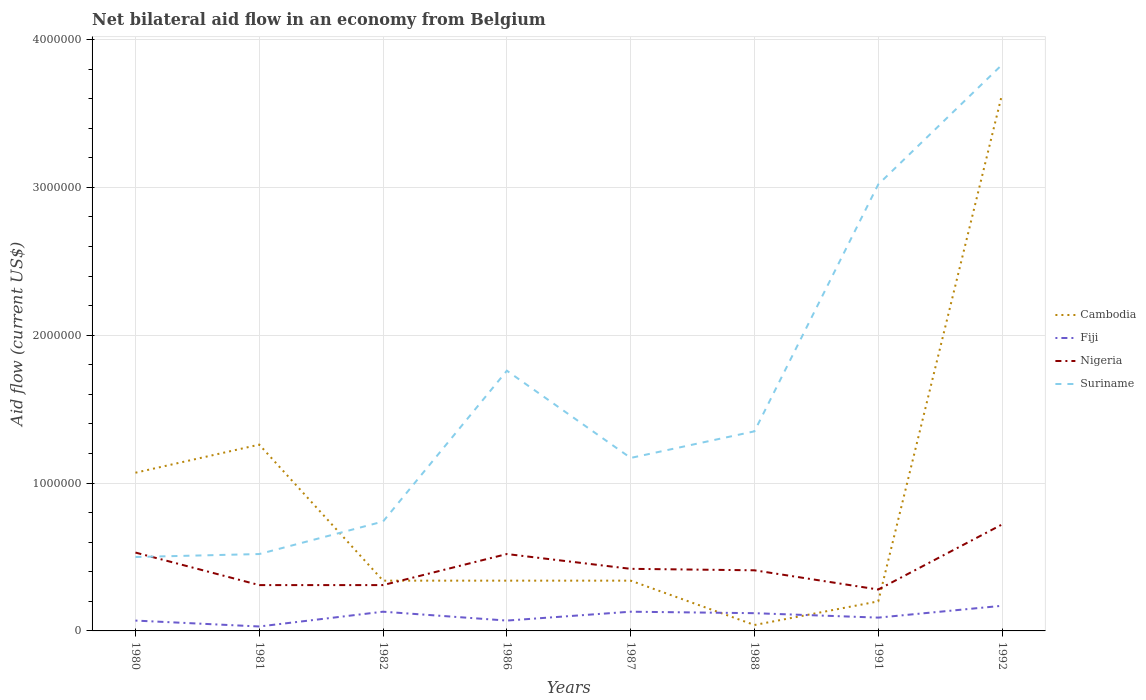Does the line corresponding to Suriname intersect with the line corresponding to Nigeria?
Your answer should be compact. Yes. Is the number of lines equal to the number of legend labels?
Offer a very short reply. Yes. What is the difference between the highest and the second highest net bilateral aid flow in Suriname?
Provide a short and direct response. 3.33e+06. What is the difference between the highest and the lowest net bilateral aid flow in Fiji?
Provide a succinct answer. 4. How many lines are there?
Ensure brevity in your answer.  4. Are the values on the major ticks of Y-axis written in scientific E-notation?
Ensure brevity in your answer.  No. Does the graph contain grids?
Provide a succinct answer. Yes. How many legend labels are there?
Offer a very short reply. 4. How are the legend labels stacked?
Provide a short and direct response. Vertical. What is the title of the graph?
Offer a terse response. Net bilateral aid flow in an economy from Belgium. Does "Least developed countries" appear as one of the legend labels in the graph?
Offer a terse response. No. What is the label or title of the Y-axis?
Your answer should be very brief. Aid flow (current US$). What is the Aid flow (current US$) of Cambodia in 1980?
Provide a short and direct response. 1.07e+06. What is the Aid flow (current US$) in Fiji in 1980?
Make the answer very short. 7.00e+04. What is the Aid flow (current US$) of Nigeria in 1980?
Offer a terse response. 5.30e+05. What is the Aid flow (current US$) in Suriname in 1980?
Offer a terse response. 5.00e+05. What is the Aid flow (current US$) of Cambodia in 1981?
Provide a short and direct response. 1.26e+06. What is the Aid flow (current US$) of Fiji in 1981?
Provide a short and direct response. 3.00e+04. What is the Aid flow (current US$) of Nigeria in 1981?
Give a very brief answer. 3.10e+05. What is the Aid flow (current US$) of Suriname in 1981?
Your answer should be very brief. 5.20e+05. What is the Aid flow (current US$) of Fiji in 1982?
Your response must be concise. 1.30e+05. What is the Aid flow (current US$) of Suriname in 1982?
Your answer should be very brief. 7.40e+05. What is the Aid flow (current US$) of Fiji in 1986?
Your answer should be compact. 7.00e+04. What is the Aid flow (current US$) in Nigeria in 1986?
Your answer should be compact. 5.20e+05. What is the Aid flow (current US$) in Suriname in 1986?
Keep it short and to the point. 1.76e+06. What is the Aid flow (current US$) in Nigeria in 1987?
Provide a succinct answer. 4.20e+05. What is the Aid flow (current US$) of Suriname in 1987?
Your answer should be very brief. 1.17e+06. What is the Aid flow (current US$) of Cambodia in 1988?
Your response must be concise. 4.00e+04. What is the Aid flow (current US$) of Fiji in 1988?
Your answer should be compact. 1.20e+05. What is the Aid flow (current US$) in Suriname in 1988?
Offer a terse response. 1.35e+06. What is the Aid flow (current US$) of Nigeria in 1991?
Offer a very short reply. 2.80e+05. What is the Aid flow (current US$) of Suriname in 1991?
Offer a very short reply. 3.02e+06. What is the Aid flow (current US$) in Cambodia in 1992?
Make the answer very short. 3.63e+06. What is the Aid flow (current US$) in Fiji in 1992?
Provide a short and direct response. 1.70e+05. What is the Aid flow (current US$) of Nigeria in 1992?
Your response must be concise. 7.20e+05. What is the Aid flow (current US$) in Suriname in 1992?
Provide a short and direct response. 3.83e+06. Across all years, what is the maximum Aid flow (current US$) in Cambodia?
Make the answer very short. 3.63e+06. Across all years, what is the maximum Aid flow (current US$) of Fiji?
Your response must be concise. 1.70e+05. Across all years, what is the maximum Aid flow (current US$) in Nigeria?
Provide a succinct answer. 7.20e+05. Across all years, what is the maximum Aid flow (current US$) in Suriname?
Offer a very short reply. 3.83e+06. Across all years, what is the minimum Aid flow (current US$) of Nigeria?
Keep it short and to the point. 2.80e+05. What is the total Aid flow (current US$) of Cambodia in the graph?
Provide a short and direct response. 7.22e+06. What is the total Aid flow (current US$) in Fiji in the graph?
Provide a short and direct response. 8.10e+05. What is the total Aid flow (current US$) in Nigeria in the graph?
Ensure brevity in your answer.  3.50e+06. What is the total Aid flow (current US$) in Suriname in the graph?
Your answer should be compact. 1.29e+07. What is the difference between the Aid flow (current US$) in Cambodia in 1980 and that in 1981?
Make the answer very short. -1.90e+05. What is the difference between the Aid flow (current US$) of Suriname in 1980 and that in 1981?
Keep it short and to the point. -2.00e+04. What is the difference between the Aid flow (current US$) in Cambodia in 1980 and that in 1982?
Offer a terse response. 7.30e+05. What is the difference between the Aid flow (current US$) in Fiji in 1980 and that in 1982?
Make the answer very short. -6.00e+04. What is the difference between the Aid flow (current US$) in Nigeria in 1980 and that in 1982?
Keep it short and to the point. 2.20e+05. What is the difference between the Aid flow (current US$) in Suriname in 1980 and that in 1982?
Your response must be concise. -2.40e+05. What is the difference between the Aid flow (current US$) of Cambodia in 1980 and that in 1986?
Your answer should be compact. 7.30e+05. What is the difference between the Aid flow (current US$) of Fiji in 1980 and that in 1986?
Keep it short and to the point. 0. What is the difference between the Aid flow (current US$) in Suriname in 1980 and that in 1986?
Provide a succinct answer. -1.26e+06. What is the difference between the Aid flow (current US$) of Cambodia in 1980 and that in 1987?
Provide a succinct answer. 7.30e+05. What is the difference between the Aid flow (current US$) of Suriname in 1980 and that in 1987?
Provide a short and direct response. -6.70e+05. What is the difference between the Aid flow (current US$) of Cambodia in 1980 and that in 1988?
Your response must be concise. 1.03e+06. What is the difference between the Aid flow (current US$) of Suriname in 1980 and that in 1988?
Your answer should be very brief. -8.50e+05. What is the difference between the Aid flow (current US$) in Cambodia in 1980 and that in 1991?
Keep it short and to the point. 8.70e+05. What is the difference between the Aid flow (current US$) in Nigeria in 1980 and that in 1991?
Give a very brief answer. 2.50e+05. What is the difference between the Aid flow (current US$) in Suriname in 1980 and that in 1991?
Ensure brevity in your answer.  -2.52e+06. What is the difference between the Aid flow (current US$) in Cambodia in 1980 and that in 1992?
Keep it short and to the point. -2.56e+06. What is the difference between the Aid flow (current US$) of Suriname in 1980 and that in 1992?
Ensure brevity in your answer.  -3.33e+06. What is the difference between the Aid flow (current US$) of Cambodia in 1981 and that in 1982?
Provide a succinct answer. 9.20e+05. What is the difference between the Aid flow (current US$) in Suriname in 1981 and that in 1982?
Your answer should be compact. -2.20e+05. What is the difference between the Aid flow (current US$) in Cambodia in 1981 and that in 1986?
Your response must be concise. 9.20e+05. What is the difference between the Aid flow (current US$) of Fiji in 1981 and that in 1986?
Keep it short and to the point. -4.00e+04. What is the difference between the Aid flow (current US$) of Suriname in 1981 and that in 1986?
Your answer should be very brief. -1.24e+06. What is the difference between the Aid flow (current US$) in Cambodia in 1981 and that in 1987?
Give a very brief answer. 9.20e+05. What is the difference between the Aid flow (current US$) in Fiji in 1981 and that in 1987?
Your answer should be compact. -1.00e+05. What is the difference between the Aid flow (current US$) in Nigeria in 1981 and that in 1987?
Keep it short and to the point. -1.10e+05. What is the difference between the Aid flow (current US$) of Suriname in 1981 and that in 1987?
Give a very brief answer. -6.50e+05. What is the difference between the Aid flow (current US$) in Cambodia in 1981 and that in 1988?
Provide a succinct answer. 1.22e+06. What is the difference between the Aid flow (current US$) in Fiji in 1981 and that in 1988?
Offer a terse response. -9.00e+04. What is the difference between the Aid flow (current US$) of Suriname in 1981 and that in 1988?
Ensure brevity in your answer.  -8.30e+05. What is the difference between the Aid flow (current US$) in Cambodia in 1981 and that in 1991?
Make the answer very short. 1.06e+06. What is the difference between the Aid flow (current US$) in Nigeria in 1981 and that in 1991?
Make the answer very short. 3.00e+04. What is the difference between the Aid flow (current US$) in Suriname in 1981 and that in 1991?
Offer a very short reply. -2.50e+06. What is the difference between the Aid flow (current US$) in Cambodia in 1981 and that in 1992?
Your answer should be very brief. -2.37e+06. What is the difference between the Aid flow (current US$) of Fiji in 1981 and that in 1992?
Give a very brief answer. -1.40e+05. What is the difference between the Aid flow (current US$) in Nigeria in 1981 and that in 1992?
Your response must be concise. -4.10e+05. What is the difference between the Aid flow (current US$) of Suriname in 1981 and that in 1992?
Keep it short and to the point. -3.31e+06. What is the difference between the Aid flow (current US$) in Cambodia in 1982 and that in 1986?
Give a very brief answer. 0. What is the difference between the Aid flow (current US$) of Fiji in 1982 and that in 1986?
Your answer should be compact. 6.00e+04. What is the difference between the Aid flow (current US$) in Nigeria in 1982 and that in 1986?
Keep it short and to the point. -2.10e+05. What is the difference between the Aid flow (current US$) of Suriname in 1982 and that in 1986?
Make the answer very short. -1.02e+06. What is the difference between the Aid flow (current US$) of Fiji in 1982 and that in 1987?
Your response must be concise. 0. What is the difference between the Aid flow (current US$) in Nigeria in 1982 and that in 1987?
Your answer should be very brief. -1.10e+05. What is the difference between the Aid flow (current US$) of Suriname in 1982 and that in 1987?
Ensure brevity in your answer.  -4.30e+05. What is the difference between the Aid flow (current US$) of Fiji in 1982 and that in 1988?
Give a very brief answer. 10000. What is the difference between the Aid flow (current US$) of Nigeria in 1982 and that in 1988?
Give a very brief answer. -1.00e+05. What is the difference between the Aid flow (current US$) of Suriname in 1982 and that in 1988?
Provide a succinct answer. -6.10e+05. What is the difference between the Aid flow (current US$) in Cambodia in 1982 and that in 1991?
Provide a short and direct response. 1.40e+05. What is the difference between the Aid flow (current US$) of Nigeria in 1982 and that in 1991?
Offer a very short reply. 3.00e+04. What is the difference between the Aid flow (current US$) in Suriname in 1982 and that in 1991?
Give a very brief answer. -2.28e+06. What is the difference between the Aid flow (current US$) of Cambodia in 1982 and that in 1992?
Offer a very short reply. -3.29e+06. What is the difference between the Aid flow (current US$) of Fiji in 1982 and that in 1992?
Ensure brevity in your answer.  -4.00e+04. What is the difference between the Aid flow (current US$) in Nigeria in 1982 and that in 1992?
Offer a very short reply. -4.10e+05. What is the difference between the Aid flow (current US$) in Suriname in 1982 and that in 1992?
Ensure brevity in your answer.  -3.09e+06. What is the difference between the Aid flow (current US$) in Nigeria in 1986 and that in 1987?
Your answer should be compact. 1.00e+05. What is the difference between the Aid flow (current US$) of Suriname in 1986 and that in 1987?
Your response must be concise. 5.90e+05. What is the difference between the Aid flow (current US$) of Fiji in 1986 and that in 1988?
Your answer should be very brief. -5.00e+04. What is the difference between the Aid flow (current US$) of Nigeria in 1986 and that in 1988?
Offer a very short reply. 1.10e+05. What is the difference between the Aid flow (current US$) of Cambodia in 1986 and that in 1991?
Your response must be concise. 1.40e+05. What is the difference between the Aid flow (current US$) of Fiji in 1986 and that in 1991?
Give a very brief answer. -2.00e+04. What is the difference between the Aid flow (current US$) of Suriname in 1986 and that in 1991?
Provide a succinct answer. -1.26e+06. What is the difference between the Aid flow (current US$) in Cambodia in 1986 and that in 1992?
Keep it short and to the point. -3.29e+06. What is the difference between the Aid flow (current US$) in Nigeria in 1986 and that in 1992?
Ensure brevity in your answer.  -2.00e+05. What is the difference between the Aid flow (current US$) of Suriname in 1986 and that in 1992?
Your response must be concise. -2.07e+06. What is the difference between the Aid flow (current US$) in Fiji in 1987 and that in 1988?
Provide a succinct answer. 10000. What is the difference between the Aid flow (current US$) in Nigeria in 1987 and that in 1991?
Give a very brief answer. 1.40e+05. What is the difference between the Aid flow (current US$) in Suriname in 1987 and that in 1991?
Offer a terse response. -1.85e+06. What is the difference between the Aid flow (current US$) in Cambodia in 1987 and that in 1992?
Your answer should be compact. -3.29e+06. What is the difference between the Aid flow (current US$) of Nigeria in 1987 and that in 1992?
Offer a very short reply. -3.00e+05. What is the difference between the Aid flow (current US$) of Suriname in 1987 and that in 1992?
Make the answer very short. -2.66e+06. What is the difference between the Aid flow (current US$) in Cambodia in 1988 and that in 1991?
Offer a terse response. -1.60e+05. What is the difference between the Aid flow (current US$) in Fiji in 1988 and that in 1991?
Provide a short and direct response. 3.00e+04. What is the difference between the Aid flow (current US$) of Nigeria in 1988 and that in 1991?
Keep it short and to the point. 1.30e+05. What is the difference between the Aid flow (current US$) in Suriname in 1988 and that in 1991?
Give a very brief answer. -1.67e+06. What is the difference between the Aid flow (current US$) in Cambodia in 1988 and that in 1992?
Your response must be concise. -3.59e+06. What is the difference between the Aid flow (current US$) of Fiji in 1988 and that in 1992?
Your response must be concise. -5.00e+04. What is the difference between the Aid flow (current US$) in Nigeria in 1988 and that in 1992?
Provide a short and direct response. -3.10e+05. What is the difference between the Aid flow (current US$) in Suriname in 1988 and that in 1992?
Give a very brief answer. -2.48e+06. What is the difference between the Aid flow (current US$) in Cambodia in 1991 and that in 1992?
Provide a short and direct response. -3.43e+06. What is the difference between the Aid flow (current US$) of Nigeria in 1991 and that in 1992?
Offer a very short reply. -4.40e+05. What is the difference between the Aid flow (current US$) in Suriname in 1991 and that in 1992?
Keep it short and to the point. -8.10e+05. What is the difference between the Aid flow (current US$) of Cambodia in 1980 and the Aid flow (current US$) of Fiji in 1981?
Offer a very short reply. 1.04e+06. What is the difference between the Aid flow (current US$) in Cambodia in 1980 and the Aid flow (current US$) in Nigeria in 1981?
Ensure brevity in your answer.  7.60e+05. What is the difference between the Aid flow (current US$) of Fiji in 1980 and the Aid flow (current US$) of Suriname in 1981?
Offer a terse response. -4.50e+05. What is the difference between the Aid flow (current US$) in Cambodia in 1980 and the Aid flow (current US$) in Fiji in 1982?
Provide a short and direct response. 9.40e+05. What is the difference between the Aid flow (current US$) of Cambodia in 1980 and the Aid flow (current US$) of Nigeria in 1982?
Offer a terse response. 7.60e+05. What is the difference between the Aid flow (current US$) of Fiji in 1980 and the Aid flow (current US$) of Suriname in 1982?
Provide a short and direct response. -6.70e+05. What is the difference between the Aid flow (current US$) in Nigeria in 1980 and the Aid flow (current US$) in Suriname in 1982?
Keep it short and to the point. -2.10e+05. What is the difference between the Aid flow (current US$) of Cambodia in 1980 and the Aid flow (current US$) of Nigeria in 1986?
Your answer should be very brief. 5.50e+05. What is the difference between the Aid flow (current US$) in Cambodia in 1980 and the Aid flow (current US$) in Suriname in 1986?
Make the answer very short. -6.90e+05. What is the difference between the Aid flow (current US$) of Fiji in 1980 and the Aid flow (current US$) of Nigeria in 1986?
Give a very brief answer. -4.50e+05. What is the difference between the Aid flow (current US$) in Fiji in 1980 and the Aid flow (current US$) in Suriname in 1986?
Your response must be concise. -1.69e+06. What is the difference between the Aid flow (current US$) of Nigeria in 1980 and the Aid flow (current US$) of Suriname in 1986?
Offer a very short reply. -1.23e+06. What is the difference between the Aid flow (current US$) of Cambodia in 1980 and the Aid flow (current US$) of Fiji in 1987?
Ensure brevity in your answer.  9.40e+05. What is the difference between the Aid flow (current US$) in Cambodia in 1980 and the Aid flow (current US$) in Nigeria in 1987?
Keep it short and to the point. 6.50e+05. What is the difference between the Aid flow (current US$) of Fiji in 1980 and the Aid flow (current US$) of Nigeria in 1987?
Your answer should be very brief. -3.50e+05. What is the difference between the Aid flow (current US$) of Fiji in 1980 and the Aid flow (current US$) of Suriname in 1987?
Your answer should be compact. -1.10e+06. What is the difference between the Aid flow (current US$) of Nigeria in 1980 and the Aid flow (current US$) of Suriname in 1987?
Your response must be concise. -6.40e+05. What is the difference between the Aid flow (current US$) in Cambodia in 1980 and the Aid flow (current US$) in Fiji in 1988?
Ensure brevity in your answer.  9.50e+05. What is the difference between the Aid flow (current US$) of Cambodia in 1980 and the Aid flow (current US$) of Nigeria in 1988?
Your response must be concise. 6.60e+05. What is the difference between the Aid flow (current US$) of Cambodia in 1980 and the Aid flow (current US$) of Suriname in 1988?
Offer a terse response. -2.80e+05. What is the difference between the Aid flow (current US$) of Fiji in 1980 and the Aid flow (current US$) of Suriname in 1988?
Provide a succinct answer. -1.28e+06. What is the difference between the Aid flow (current US$) in Nigeria in 1980 and the Aid flow (current US$) in Suriname in 1988?
Your response must be concise. -8.20e+05. What is the difference between the Aid flow (current US$) of Cambodia in 1980 and the Aid flow (current US$) of Fiji in 1991?
Your answer should be very brief. 9.80e+05. What is the difference between the Aid flow (current US$) in Cambodia in 1980 and the Aid flow (current US$) in Nigeria in 1991?
Provide a short and direct response. 7.90e+05. What is the difference between the Aid flow (current US$) of Cambodia in 1980 and the Aid flow (current US$) of Suriname in 1991?
Keep it short and to the point. -1.95e+06. What is the difference between the Aid flow (current US$) of Fiji in 1980 and the Aid flow (current US$) of Nigeria in 1991?
Ensure brevity in your answer.  -2.10e+05. What is the difference between the Aid flow (current US$) of Fiji in 1980 and the Aid flow (current US$) of Suriname in 1991?
Ensure brevity in your answer.  -2.95e+06. What is the difference between the Aid flow (current US$) in Nigeria in 1980 and the Aid flow (current US$) in Suriname in 1991?
Provide a succinct answer. -2.49e+06. What is the difference between the Aid flow (current US$) of Cambodia in 1980 and the Aid flow (current US$) of Fiji in 1992?
Your answer should be very brief. 9.00e+05. What is the difference between the Aid flow (current US$) in Cambodia in 1980 and the Aid flow (current US$) in Suriname in 1992?
Ensure brevity in your answer.  -2.76e+06. What is the difference between the Aid flow (current US$) in Fiji in 1980 and the Aid flow (current US$) in Nigeria in 1992?
Offer a very short reply. -6.50e+05. What is the difference between the Aid flow (current US$) of Fiji in 1980 and the Aid flow (current US$) of Suriname in 1992?
Provide a succinct answer. -3.76e+06. What is the difference between the Aid flow (current US$) of Nigeria in 1980 and the Aid flow (current US$) of Suriname in 1992?
Your answer should be compact. -3.30e+06. What is the difference between the Aid flow (current US$) of Cambodia in 1981 and the Aid flow (current US$) of Fiji in 1982?
Your response must be concise. 1.13e+06. What is the difference between the Aid flow (current US$) in Cambodia in 1981 and the Aid flow (current US$) in Nigeria in 1982?
Ensure brevity in your answer.  9.50e+05. What is the difference between the Aid flow (current US$) of Cambodia in 1981 and the Aid flow (current US$) of Suriname in 1982?
Give a very brief answer. 5.20e+05. What is the difference between the Aid flow (current US$) in Fiji in 1981 and the Aid flow (current US$) in Nigeria in 1982?
Offer a terse response. -2.80e+05. What is the difference between the Aid flow (current US$) in Fiji in 1981 and the Aid flow (current US$) in Suriname in 1982?
Provide a succinct answer. -7.10e+05. What is the difference between the Aid flow (current US$) in Nigeria in 1981 and the Aid flow (current US$) in Suriname in 1982?
Provide a short and direct response. -4.30e+05. What is the difference between the Aid flow (current US$) in Cambodia in 1981 and the Aid flow (current US$) in Fiji in 1986?
Your answer should be very brief. 1.19e+06. What is the difference between the Aid flow (current US$) in Cambodia in 1981 and the Aid flow (current US$) in Nigeria in 1986?
Your response must be concise. 7.40e+05. What is the difference between the Aid flow (current US$) in Cambodia in 1981 and the Aid flow (current US$) in Suriname in 1986?
Provide a succinct answer. -5.00e+05. What is the difference between the Aid flow (current US$) in Fiji in 1981 and the Aid flow (current US$) in Nigeria in 1986?
Your answer should be very brief. -4.90e+05. What is the difference between the Aid flow (current US$) in Fiji in 1981 and the Aid flow (current US$) in Suriname in 1986?
Ensure brevity in your answer.  -1.73e+06. What is the difference between the Aid flow (current US$) in Nigeria in 1981 and the Aid flow (current US$) in Suriname in 1986?
Your answer should be very brief. -1.45e+06. What is the difference between the Aid flow (current US$) in Cambodia in 1981 and the Aid flow (current US$) in Fiji in 1987?
Your answer should be very brief. 1.13e+06. What is the difference between the Aid flow (current US$) in Cambodia in 1981 and the Aid flow (current US$) in Nigeria in 1987?
Your response must be concise. 8.40e+05. What is the difference between the Aid flow (current US$) of Fiji in 1981 and the Aid flow (current US$) of Nigeria in 1987?
Provide a short and direct response. -3.90e+05. What is the difference between the Aid flow (current US$) in Fiji in 1981 and the Aid flow (current US$) in Suriname in 1987?
Provide a succinct answer. -1.14e+06. What is the difference between the Aid flow (current US$) in Nigeria in 1981 and the Aid flow (current US$) in Suriname in 1987?
Offer a terse response. -8.60e+05. What is the difference between the Aid flow (current US$) in Cambodia in 1981 and the Aid flow (current US$) in Fiji in 1988?
Your answer should be very brief. 1.14e+06. What is the difference between the Aid flow (current US$) of Cambodia in 1981 and the Aid flow (current US$) of Nigeria in 1988?
Provide a succinct answer. 8.50e+05. What is the difference between the Aid flow (current US$) in Fiji in 1981 and the Aid flow (current US$) in Nigeria in 1988?
Offer a very short reply. -3.80e+05. What is the difference between the Aid flow (current US$) of Fiji in 1981 and the Aid flow (current US$) of Suriname in 1988?
Keep it short and to the point. -1.32e+06. What is the difference between the Aid flow (current US$) of Nigeria in 1981 and the Aid flow (current US$) of Suriname in 1988?
Give a very brief answer. -1.04e+06. What is the difference between the Aid flow (current US$) of Cambodia in 1981 and the Aid flow (current US$) of Fiji in 1991?
Your answer should be very brief. 1.17e+06. What is the difference between the Aid flow (current US$) in Cambodia in 1981 and the Aid flow (current US$) in Nigeria in 1991?
Your response must be concise. 9.80e+05. What is the difference between the Aid flow (current US$) in Cambodia in 1981 and the Aid flow (current US$) in Suriname in 1991?
Give a very brief answer. -1.76e+06. What is the difference between the Aid flow (current US$) of Fiji in 1981 and the Aid flow (current US$) of Suriname in 1991?
Keep it short and to the point. -2.99e+06. What is the difference between the Aid flow (current US$) in Nigeria in 1981 and the Aid flow (current US$) in Suriname in 1991?
Make the answer very short. -2.71e+06. What is the difference between the Aid flow (current US$) in Cambodia in 1981 and the Aid flow (current US$) in Fiji in 1992?
Offer a terse response. 1.09e+06. What is the difference between the Aid flow (current US$) in Cambodia in 1981 and the Aid flow (current US$) in Nigeria in 1992?
Offer a terse response. 5.40e+05. What is the difference between the Aid flow (current US$) in Cambodia in 1981 and the Aid flow (current US$) in Suriname in 1992?
Give a very brief answer. -2.57e+06. What is the difference between the Aid flow (current US$) in Fiji in 1981 and the Aid flow (current US$) in Nigeria in 1992?
Offer a terse response. -6.90e+05. What is the difference between the Aid flow (current US$) of Fiji in 1981 and the Aid flow (current US$) of Suriname in 1992?
Offer a terse response. -3.80e+06. What is the difference between the Aid flow (current US$) of Nigeria in 1981 and the Aid flow (current US$) of Suriname in 1992?
Give a very brief answer. -3.52e+06. What is the difference between the Aid flow (current US$) of Cambodia in 1982 and the Aid flow (current US$) of Nigeria in 1986?
Offer a very short reply. -1.80e+05. What is the difference between the Aid flow (current US$) of Cambodia in 1982 and the Aid flow (current US$) of Suriname in 1986?
Keep it short and to the point. -1.42e+06. What is the difference between the Aid flow (current US$) of Fiji in 1982 and the Aid flow (current US$) of Nigeria in 1986?
Offer a very short reply. -3.90e+05. What is the difference between the Aid flow (current US$) in Fiji in 1982 and the Aid flow (current US$) in Suriname in 1986?
Your answer should be very brief. -1.63e+06. What is the difference between the Aid flow (current US$) in Nigeria in 1982 and the Aid flow (current US$) in Suriname in 1986?
Keep it short and to the point. -1.45e+06. What is the difference between the Aid flow (current US$) of Cambodia in 1982 and the Aid flow (current US$) of Fiji in 1987?
Give a very brief answer. 2.10e+05. What is the difference between the Aid flow (current US$) of Cambodia in 1982 and the Aid flow (current US$) of Suriname in 1987?
Offer a very short reply. -8.30e+05. What is the difference between the Aid flow (current US$) of Fiji in 1982 and the Aid flow (current US$) of Nigeria in 1987?
Provide a succinct answer. -2.90e+05. What is the difference between the Aid flow (current US$) of Fiji in 1982 and the Aid flow (current US$) of Suriname in 1987?
Give a very brief answer. -1.04e+06. What is the difference between the Aid flow (current US$) of Nigeria in 1982 and the Aid flow (current US$) of Suriname in 1987?
Offer a very short reply. -8.60e+05. What is the difference between the Aid flow (current US$) of Cambodia in 1982 and the Aid flow (current US$) of Fiji in 1988?
Make the answer very short. 2.20e+05. What is the difference between the Aid flow (current US$) of Cambodia in 1982 and the Aid flow (current US$) of Suriname in 1988?
Give a very brief answer. -1.01e+06. What is the difference between the Aid flow (current US$) in Fiji in 1982 and the Aid flow (current US$) in Nigeria in 1988?
Your response must be concise. -2.80e+05. What is the difference between the Aid flow (current US$) in Fiji in 1982 and the Aid flow (current US$) in Suriname in 1988?
Give a very brief answer. -1.22e+06. What is the difference between the Aid flow (current US$) of Nigeria in 1982 and the Aid flow (current US$) of Suriname in 1988?
Provide a short and direct response. -1.04e+06. What is the difference between the Aid flow (current US$) in Cambodia in 1982 and the Aid flow (current US$) in Fiji in 1991?
Your response must be concise. 2.50e+05. What is the difference between the Aid flow (current US$) of Cambodia in 1982 and the Aid flow (current US$) of Nigeria in 1991?
Offer a very short reply. 6.00e+04. What is the difference between the Aid flow (current US$) in Cambodia in 1982 and the Aid flow (current US$) in Suriname in 1991?
Your response must be concise. -2.68e+06. What is the difference between the Aid flow (current US$) of Fiji in 1982 and the Aid flow (current US$) of Suriname in 1991?
Your answer should be very brief. -2.89e+06. What is the difference between the Aid flow (current US$) of Nigeria in 1982 and the Aid flow (current US$) of Suriname in 1991?
Offer a very short reply. -2.71e+06. What is the difference between the Aid flow (current US$) of Cambodia in 1982 and the Aid flow (current US$) of Fiji in 1992?
Your answer should be compact. 1.70e+05. What is the difference between the Aid flow (current US$) in Cambodia in 1982 and the Aid flow (current US$) in Nigeria in 1992?
Make the answer very short. -3.80e+05. What is the difference between the Aid flow (current US$) of Cambodia in 1982 and the Aid flow (current US$) of Suriname in 1992?
Give a very brief answer. -3.49e+06. What is the difference between the Aid flow (current US$) of Fiji in 1982 and the Aid flow (current US$) of Nigeria in 1992?
Make the answer very short. -5.90e+05. What is the difference between the Aid flow (current US$) of Fiji in 1982 and the Aid flow (current US$) of Suriname in 1992?
Offer a very short reply. -3.70e+06. What is the difference between the Aid flow (current US$) in Nigeria in 1982 and the Aid flow (current US$) in Suriname in 1992?
Make the answer very short. -3.52e+06. What is the difference between the Aid flow (current US$) of Cambodia in 1986 and the Aid flow (current US$) of Fiji in 1987?
Your response must be concise. 2.10e+05. What is the difference between the Aid flow (current US$) of Cambodia in 1986 and the Aid flow (current US$) of Nigeria in 1987?
Offer a terse response. -8.00e+04. What is the difference between the Aid flow (current US$) of Cambodia in 1986 and the Aid flow (current US$) of Suriname in 1987?
Your answer should be very brief. -8.30e+05. What is the difference between the Aid flow (current US$) of Fiji in 1986 and the Aid flow (current US$) of Nigeria in 1987?
Provide a succinct answer. -3.50e+05. What is the difference between the Aid flow (current US$) in Fiji in 1986 and the Aid flow (current US$) in Suriname in 1987?
Make the answer very short. -1.10e+06. What is the difference between the Aid flow (current US$) of Nigeria in 1986 and the Aid flow (current US$) of Suriname in 1987?
Offer a terse response. -6.50e+05. What is the difference between the Aid flow (current US$) in Cambodia in 1986 and the Aid flow (current US$) in Nigeria in 1988?
Offer a terse response. -7.00e+04. What is the difference between the Aid flow (current US$) of Cambodia in 1986 and the Aid flow (current US$) of Suriname in 1988?
Your answer should be very brief. -1.01e+06. What is the difference between the Aid flow (current US$) of Fiji in 1986 and the Aid flow (current US$) of Nigeria in 1988?
Offer a very short reply. -3.40e+05. What is the difference between the Aid flow (current US$) in Fiji in 1986 and the Aid flow (current US$) in Suriname in 1988?
Offer a terse response. -1.28e+06. What is the difference between the Aid flow (current US$) of Nigeria in 1986 and the Aid flow (current US$) of Suriname in 1988?
Offer a terse response. -8.30e+05. What is the difference between the Aid flow (current US$) in Cambodia in 1986 and the Aid flow (current US$) in Fiji in 1991?
Provide a succinct answer. 2.50e+05. What is the difference between the Aid flow (current US$) of Cambodia in 1986 and the Aid flow (current US$) of Suriname in 1991?
Offer a very short reply. -2.68e+06. What is the difference between the Aid flow (current US$) in Fiji in 1986 and the Aid flow (current US$) in Suriname in 1991?
Ensure brevity in your answer.  -2.95e+06. What is the difference between the Aid flow (current US$) of Nigeria in 1986 and the Aid flow (current US$) of Suriname in 1991?
Offer a terse response. -2.50e+06. What is the difference between the Aid flow (current US$) in Cambodia in 1986 and the Aid flow (current US$) in Fiji in 1992?
Provide a succinct answer. 1.70e+05. What is the difference between the Aid flow (current US$) of Cambodia in 1986 and the Aid flow (current US$) of Nigeria in 1992?
Your response must be concise. -3.80e+05. What is the difference between the Aid flow (current US$) in Cambodia in 1986 and the Aid flow (current US$) in Suriname in 1992?
Your answer should be compact. -3.49e+06. What is the difference between the Aid flow (current US$) of Fiji in 1986 and the Aid flow (current US$) of Nigeria in 1992?
Offer a very short reply. -6.50e+05. What is the difference between the Aid flow (current US$) in Fiji in 1986 and the Aid flow (current US$) in Suriname in 1992?
Provide a succinct answer. -3.76e+06. What is the difference between the Aid flow (current US$) in Nigeria in 1986 and the Aid flow (current US$) in Suriname in 1992?
Provide a succinct answer. -3.31e+06. What is the difference between the Aid flow (current US$) in Cambodia in 1987 and the Aid flow (current US$) in Fiji in 1988?
Give a very brief answer. 2.20e+05. What is the difference between the Aid flow (current US$) in Cambodia in 1987 and the Aid flow (current US$) in Suriname in 1988?
Offer a terse response. -1.01e+06. What is the difference between the Aid flow (current US$) in Fiji in 1987 and the Aid flow (current US$) in Nigeria in 1988?
Offer a terse response. -2.80e+05. What is the difference between the Aid flow (current US$) of Fiji in 1987 and the Aid flow (current US$) of Suriname in 1988?
Provide a succinct answer. -1.22e+06. What is the difference between the Aid flow (current US$) in Nigeria in 1987 and the Aid flow (current US$) in Suriname in 1988?
Ensure brevity in your answer.  -9.30e+05. What is the difference between the Aid flow (current US$) in Cambodia in 1987 and the Aid flow (current US$) in Fiji in 1991?
Offer a terse response. 2.50e+05. What is the difference between the Aid flow (current US$) of Cambodia in 1987 and the Aid flow (current US$) of Suriname in 1991?
Your response must be concise. -2.68e+06. What is the difference between the Aid flow (current US$) in Fiji in 1987 and the Aid flow (current US$) in Suriname in 1991?
Your answer should be compact. -2.89e+06. What is the difference between the Aid flow (current US$) of Nigeria in 1987 and the Aid flow (current US$) of Suriname in 1991?
Your response must be concise. -2.60e+06. What is the difference between the Aid flow (current US$) of Cambodia in 1987 and the Aid flow (current US$) of Fiji in 1992?
Offer a terse response. 1.70e+05. What is the difference between the Aid flow (current US$) in Cambodia in 1987 and the Aid flow (current US$) in Nigeria in 1992?
Your answer should be compact. -3.80e+05. What is the difference between the Aid flow (current US$) of Cambodia in 1987 and the Aid flow (current US$) of Suriname in 1992?
Offer a very short reply. -3.49e+06. What is the difference between the Aid flow (current US$) in Fiji in 1987 and the Aid flow (current US$) in Nigeria in 1992?
Make the answer very short. -5.90e+05. What is the difference between the Aid flow (current US$) of Fiji in 1987 and the Aid flow (current US$) of Suriname in 1992?
Your answer should be compact. -3.70e+06. What is the difference between the Aid flow (current US$) in Nigeria in 1987 and the Aid flow (current US$) in Suriname in 1992?
Provide a short and direct response. -3.41e+06. What is the difference between the Aid flow (current US$) of Cambodia in 1988 and the Aid flow (current US$) of Nigeria in 1991?
Your answer should be compact. -2.40e+05. What is the difference between the Aid flow (current US$) in Cambodia in 1988 and the Aid flow (current US$) in Suriname in 1991?
Offer a very short reply. -2.98e+06. What is the difference between the Aid flow (current US$) in Fiji in 1988 and the Aid flow (current US$) in Suriname in 1991?
Offer a terse response. -2.90e+06. What is the difference between the Aid flow (current US$) in Nigeria in 1988 and the Aid flow (current US$) in Suriname in 1991?
Offer a terse response. -2.61e+06. What is the difference between the Aid flow (current US$) of Cambodia in 1988 and the Aid flow (current US$) of Nigeria in 1992?
Ensure brevity in your answer.  -6.80e+05. What is the difference between the Aid flow (current US$) in Cambodia in 1988 and the Aid flow (current US$) in Suriname in 1992?
Ensure brevity in your answer.  -3.79e+06. What is the difference between the Aid flow (current US$) of Fiji in 1988 and the Aid flow (current US$) of Nigeria in 1992?
Provide a short and direct response. -6.00e+05. What is the difference between the Aid flow (current US$) in Fiji in 1988 and the Aid flow (current US$) in Suriname in 1992?
Your answer should be very brief. -3.71e+06. What is the difference between the Aid flow (current US$) in Nigeria in 1988 and the Aid flow (current US$) in Suriname in 1992?
Your response must be concise. -3.42e+06. What is the difference between the Aid flow (current US$) of Cambodia in 1991 and the Aid flow (current US$) of Nigeria in 1992?
Make the answer very short. -5.20e+05. What is the difference between the Aid flow (current US$) in Cambodia in 1991 and the Aid flow (current US$) in Suriname in 1992?
Make the answer very short. -3.63e+06. What is the difference between the Aid flow (current US$) of Fiji in 1991 and the Aid flow (current US$) of Nigeria in 1992?
Make the answer very short. -6.30e+05. What is the difference between the Aid flow (current US$) of Fiji in 1991 and the Aid flow (current US$) of Suriname in 1992?
Keep it short and to the point. -3.74e+06. What is the difference between the Aid flow (current US$) of Nigeria in 1991 and the Aid flow (current US$) of Suriname in 1992?
Ensure brevity in your answer.  -3.55e+06. What is the average Aid flow (current US$) in Cambodia per year?
Make the answer very short. 9.02e+05. What is the average Aid flow (current US$) of Fiji per year?
Give a very brief answer. 1.01e+05. What is the average Aid flow (current US$) of Nigeria per year?
Make the answer very short. 4.38e+05. What is the average Aid flow (current US$) in Suriname per year?
Offer a very short reply. 1.61e+06. In the year 1980, what is the difference between the Aid flow (current US$) of Cambodia and Aid flow (current US$) of Nigeria?
Offer a very short reply. 5.40e+05. In the year 1980, what is the difference between the Aid flow (current US$) of Cambodia and Aid flow (current US$) of Suriname?
Give a very brief answer. 5.70e+05. In the year 1980, what is the difference between the Aid flow (current US$) of Fiji and Aid flow (current US$) of Nigeria?
Offer a very short reply. -4.60e+05. In the year 1980, what is the difference between the Aid flow (current US$) in Fiji and Aid flow (current US$) in Suriname?
Offer a terse response. -4.30e+05. In the year 1981, what is the difference between the Aid flow (current US$) of Cambodia and Aid flow (current US$) of Fiji?
Give a very brief answer. 1.23e+06. In the year 1981, what is the difference between the Aid flow (current US$) of Cambodia and Aid flow (current US$) of Nigeria?
Your response must be concise. 9.50e+05. In the year 1981, what is the difference between the Aid flow (current US$) in Cambodia and Aid flow (current US$) in Suriname?
Your answer should be compact. 7.40e+05. In the year 1981, what is the difference between the Aid flow (current US$) in Fiji and Aid flow (current US$) in Nigeria?
Make the answer very short. -2.80e+05. In the year 1981, what is the difference between the Aid flow (current US$) of Fiji and Aid flow (current US$) of Suriname?
Your answer should be compact. -4.90e+05. In the year 1981, what is the difference between the Aid flow (current US$) of Nigeria and Aid flow (current US$) of Suriname?
Your answer should be very brief. -2.10e+05. In the year 1982, what is the difference between the Aid flow (current US$) in Cambodia and Aid flow (current US$) in Suriname?
Offer a very short reply. -4.00e+05. In the year 1982, what is the difference between the Aid flow (current US$) in Fiji and Aid flow (current US$) in Nigeria?
Make the answer very short. -1.80e+05. In the year 1982, what is the difference between the Aid flow (current US$) of Fiji and Aid flow (current US$) of Suriname?
Make the answer very short. -6.10e+05. In the year 1982, what is the difference between the Aid flow (current US$) of Nigeria and Aid flow (current US$) of Suriname?
Keep it short and to the point. -4.30e+05. In the year 1986, what is the difference between the Aid flow (current US$) of Cambodia and Aid flow (current US$) of Suriname?
Offer a terse response. -1.42e+06. In the year 1986, what is the difference between the Aid flow (current US$) in Fiji and Aid flow (current US$) in Nigeria?
Provide a succinct answer. -4.50e+05. In the year 1986, what is the difference between the Aid flow (current US$) in Fiji and Aid flow (current US$) in Suriname?
Provide a succinct answer. -1.69e+06. In the year 1986, what is the difference between the Aid flow (current US$) of Nigeria and Aid flow (current US$) of Suriname?
Your response must be concise. -1.24e+06. In the year 1987, what is the difference between the Aid flow (current US$) in Cambodia and Aid flow (current US$) in Fiji?
Give a very brief answer. 2.10e+05. In the year 1987, what is the difference between the Aid flow (current US$) in Cambodia and Aid flow (current US$) in Suriname?
Your answer should be very brief. -8.30e+05. In the year 1987, what is the difference between the Aid flow (current US$) of Fiji and Aid flow (current US$) of Nigeria?
Your answer should be very brief. -2.90e+05. In the year 1987, what is the difference between the Aid flow (current US$) of Fiji and Aid flow (current US$) of Suriname?
Give a very brief answer. -1.04e+06. In the year 1987, what is the difference between the Aid flow (current US$) of Nigeria and Aid flow (current US$) of Suriname?
Your answer should be compact. -7.50e+05. In the year 1988, what is the difference between the Aid flow (current US$) of Cambodia and Aid flow (current US$) of Nigeria?
Give a very brief answer. -3.70e+05. In the year 1988, what is the difference between the Aid flow (current US$) in Cambodia and Aid flow (current US$) in Suriname?
Provide a short and direct response. -1.31e+06. In the year 1988, what is the difference between the Aid flow (current US$) in Fiji and Aid flow (current US$) in Nigeria?
Offer a very short reply. -2.90e+05. In the year 1988, what is the difference between the Aid flow (current US$) of Fiji and Aid flow (current US$) of Suriname?
Give a very brief answer. -1.23e+06. In the year 1988, what is the difference between the Aid flow (current US$) in Nigeria and Aid flow (current US$) in Suriname?
Ensure brevity in your answer.  -9.40e+05. In the year 1991, what is the difference between the Aid flow (current US$) in Cambodia and Aid flow (current US$) in Fiji?
Ensure brevity in your answer.  1.10e+05. In the year 1991, what is the difference between the Aid flow (current US$) of Cambodia and Aid flow (current US$) of Suriname?
Offer a terse response. -2.82e+06. In the year 1991, what is the difference between the Aid flow (current US$) in Fiji and Aid flow (current US$) in Suriname?
Offer a very short reply. -2.93e+06. In the year 1991, what is the difference between the Aid flow (current US$) in Nigeria and Aid flow (current US$) in Suriname?
Offer a terse response. -2.74e+06. In the year 1992, what is the difference between the Aid flow (current US$) in Cambodia and Aid flow (current US$) in Fiji?
Your response must be concise. 3.46e+06. In the year 1992, what is the difference between the Aid flow (current US$) of Cambodia and Aid flow (current US$) of Nigeria?
Your answer should be compact. 2.91e+06. In the year 1992, what is the difference between the Aid flow (current US$) in Fiji and Aid flow (current US$) in Nigeria?
Your response must be concise. -5.50e+05. In the year 1992, what is the difference between the Aid flow (current US$) of Fiji and Aid flow (current US$) of Suriname?
Provide a succinct answer. -3.66e+06. In the year 1992, what is the difference between the Aid flow (current US$) in Nigeria and Aid flow (current US$) in Suriname?
Your answer should be compact. -3.11e+06. What is the ratio of the Aid flow (current US$) of Cambodia in 1980 to that in 1981?
Offer a terse response. 0.85. What is the ratio of the Aid flow (current US$) of Fiji in 1980 to that in 1981?
Provide a succinct answer. 2.33. What is the ratio of the Aid flow (current US$) in Nigeria in 1980 to that in 1981?
Offer a very short reply. 1.71. What is the ratio of the Aid flow (current US$) in Suriname in 1980 to that in 1981?
Make the answer very short. 0.96. What is the ratio of the Aid flow (current US$) of Cambodia in 1980 to that in 1982?
Ensure brevity in your answer.  3.15. What is the ratio of the Aid flow (current US$) of Fiji in 1980 to that in 1982?
Ensure brevity in your answer.  0.54. What is the ratio of the Aid flow (current US$) of Nigeria in 1980 to that in 1982?
Provide a succinct answer. 1.71. What is the ratio of the Aid flow (current US$) of Suriname in 1980 to that in 1982?
Your response must be concise. 0.68. What is the ratio of the Aid flow (current US$) of Cambodia in 1980 to that in 1986?
Ensure brevity in your answer.  3.15. What is the ratio of the Aid flow (current US$) of Nigeria in 1980 to that in 1986?
Your answer should be very brief. 1.02. What is the ratio of the Aid flow (current US$) of Suriname in 1980 to that in 1986?
Make the answer very short. 0.28. What is the ratio of the Aid flow (current US$) in Cambodia in 1980 to that in 1987?
Give a very brief answer. 3.15. What is the ratio of the Aid flow (current US$) of Fiji in 1980 to that in 1987?
Your answer should be very brief. 0.54. What is the ratio of the Aid flow (current US$) in Nigeria in 1980 to that in 1987?
Offer a terse response. 1.26. What is the ratio of the Aid flow (current US$) of Suriname in 1980 to that in 1987?
Offer a very short reply. 0.43. What is the ratio of the Aid flow (current US$) in Cambodia in 1980 to that in 1988?
Your response must be concise. 26.75. What is the ratio of the Aid flow (current US$) of Fiji in 1980 to that in 1988?
Your answer should be compact. 0.58. What is the ratio of the Aid flow (current US$) of Nigeria in 1980 to that in 1988?
Provide a succinct answer. 1.29. What is the ratio of the Aid flow (current US$) of Suriname in 1980 to that in 1988?
Provide a succinct answer. 0.37. What is the ratio of the Aid flow (current US$) of Cambodia in 1980 to that in 1991?
Ensure brevity in your answer.  5.35. What is the ratio of the Aid flow (current US$) of Nigeria in 1980 to that in 1991?
Offer a very short reply. 1.89. What is the ratio of the Aid flow (current US$) in Suriname in 1980 to that in 1991?
Give a very brief answer. 0.17. What is the ratio of the Aid flow (current US$) in Cambodia in 1980 to that in 1992?
Offer a terse response. 0.29. What is the ratio of the Aid flow (current US$) in Fiji in 1980 to that in 1992?
Offer a very short reply. 0.41. What is the ratio of the Aid flow (current US$) of Nigeria in 1980 to that in 1992?
Offer a terse response. 0.74. What is the ratio of the Aid flow (current US$) in Suriname in 1980 to that in 1992?
Give a very brief answer. 0.13. What is the ratio of the Aid flow (current US$) of Cambodia in 1981 to that in 1982?
Offer a very short reply. 3.71. What is the ratio of the Aid flow (current US$) of Fiji in 1981 to that in 1982?
Provide a succinct answer. 0.23. What is the ratio of the Aid flow (current US$) in Suriname in 1981 to that in 1982?
Your answer should be very brief. 0.7. What is the ratio of the Aid flow (current US$) of Cambodia in 1981 to that in 1986?
Provide a succinct answer. 3.71. What is the ratio of the Aid flow (current US$) of Fiji in 1981 to that in 1986?
Keep it short and to the point. 0.43. What is the ratio of the Aid flow (current US$) of Nigeria in 1981 to that in 1986?
Provide a short and direct response. 0.6. What is the ratio of the Aid flow (current US$) in Suriname in 1981 to that in 1986?
Give a very brief answer. 0.3. What is the ratio of the Aid flow (current US$) of Cambodia in 1981 to that in 1987?
Keep it short and to the point. 3.71. What is the ratio of the Aid flow (current US$) in Fiji in 1981 to that in 1987?
Your answer should be compact. 0.23. What is the ratio of the Aid flow (current US$) in Nigeria in 1981 to that in 1987?
Make the answer very short. 0.74. What is the ratio of the Aid flow (current US$) in Suriname in 1981 to that in 1987?
Your response must be concise. 0.44. What is the ratio of the Aid flow (current US$) in Cambodia in 1981 to that in 1988?
Provide a succinct answer. 31.5. What is the ratio of the Aid flow (current US$) in Nigeria in 1981 to that in 1988?
Your answer should be compact. 0.76. What is the ratio of the Aid flow (current US$) of Suriname in 1981 to that in 1988?
Your response must be concise. 0.39. What is the ratio of the Aid flow (current US$) in Cambodia in 1981 to that in 1991?
Provide a short and direct response. 6.3. What is the ratio of the Aid flow (current US$) in Nigeria in 1981 to that in 1991?
Ensure brevity in your answer.  1.11. What is the ratio of the Aid flow (current US$) of Suriname in 1981 to that in 1991?
Provide a short and direct response. 0.17. What is the ratio of the Aid flow (current US$) in Cambodia in 1981 to that in 1992?
Offer a very short reply. 0.35. What is the ratio of the Aid flow (current US$) in Fiji in 1981 to that in 1992?
Make the answer very short. 0.18. What is the ratio of the Aid flow (current US$) in Nigeria in 1981 to that in 1992?
Provide a succinct answer. 0.43. What is the ratio of the Aid flow (current US$) in Suriname in 1981 to that in 1992?
Provide a succinct answer. 0.14. What is the ratio of the Aid flow (current US$) in Fiji in 1982 to that in 1986?
Your answer should be compact. 1.86. What is the ratio of the Aid flow (current US$) of Nigeria in 1982 to that in 1986?
Give a very brief answer. 0.6. What is the ratio of the Aid flow (current US$) of Suriname in 1982 to that in 1986?
Provide a succinct answer. 0.42. What is the ratio of the Aid flow (current US$) of Cambodia in 1982 to that in 1987?
Your response must be concise. 1. What is the ratio of the Aid flow (current US$) of Nigeria in 1982 to that in 1987?
Ensure brevity in your answer.  0.74. What is the ratio of the Aid flow (current US$) of Suriname in 1982 to that in 1987?
Provide a short and direct response. 0.63. What is the ratio of the Aid flow (current US$) of Nigeria in 1982 to that in 1988?
Give a very brief answer. 0.76. What is the ratio of the Aid flow (current US$) of Suriname in 1982 to that in 1988?
Provide a succinct answer. 0.55. What is the ratio of the Aid flow (current US$) in Cambodia in 1982 to that in 1991?
Give a very brief answer. 1.7. What is the ratio of the Aid flow (current US$) in Fiji in 1982 to that in 1991?
Ensure brevity in your answer.  1.44. What is the ratio of the Aid flow (current US$) in Nigeria in 1982 to that in 1991?
Offer a terse response. 1.11. What is the ratio of the Aid flow (current US$) of Suriname in 1982 to that in 1991?
Provide a short and direct response. 0.24. What is the ratio of the Aid flow (current US$) in Cambodia in 1982 to that in 1992?
Provide a short and direct response. 0.09. What is the ratio of the Aid flow (current US$) in Fiji in 1982 to that in 1992?
Provide a short and direct response. 0.76. What is the ratio of the Aid flow (current US$) of Nigeria in 1982 to that in 1992?
Provide a succinct answer. 0.43. What is the ratio of the Aid flow (current US$) of Suriname in 1982 to that in 1992?
Give a very brief answer. 0.19. What is the ratio of the Aid flow (current US$) in Cambodia in 1986 to that in 1987?
Offer a very short reply. 1. What is the ratio of the Aid flow (current US$) of Fiji in 1986 to that in 1987?
Offer a terse response. 0.54. What is the ratio of the Aid flow (current US$) of Nigeria in 1986 to that in 1987?
Ensure brevity in your answer.  1.24. What is the ratio of the Aid flow (current US$) of Suriname in 1986 to that in 1987?
Ensure brevity in your answer.  1.5. What is the ratio of the Aid flow (current US$) of Cambodia in 1986 to that in 1988?
Make the answer very short. 8.5. What is the ratio of the Aid flow (current US$) of Fiji in 1986 to that in 1988?
Provide a succinct answer. 0.58. What is the ratio of the Aid flow (current US$) of Nigeria in 1986 to that in 1988?
Give a very brief answer. 1.27. What is the ratio of the Aid flow (current US$) of Suriname in 1986 to that in 1988?
Keep it short and to the point. 1.3. What is the ratio of the Aid flow (current US$) of Cambodia in 1986 to that in 1991?
Your answer should be very brief. 1.7. What is the ratio of the Aid flow (current US$) of Fiji in 1986 to that in 1991?
Ensure brevity in your answer.  0.78. What is the ratio of the Aid flow (current US$) in Nigeria in 1986 to that in 1991?
Offer a very short reply. 1.86. What is the ratio of the Aid flow (current US$) in Suriname in 1986 to that in 1991?
Your answer should be very brief. 0.58. What is the ratio of the Aid flow (current US$) of Cambodia in 1986 to that in 1992?
Provide a short and direct response. 0.09. What is the ratio of the Aid flow (current US$) of Fiji in 1986 to that in 1992?
Provide a succinct answer. 0.41. What is the ratio of the Aid flow (current US$) in Nigeria in 1986 to that in 1992?
Offer a terse response. 0.72. What is the ratio of the Aid flow (current US$) in Suriname in 1986 to that in 1992?
Your answer should be compact. 0.46. What is the ratio of the Aid flow (current US$) of Nigeria in 1987 to that in 1988?
Offer a very short reply. 1.02. What is the ratio of the Aid flow (current US$) in Suriname in 1987 to that in 1988?
Give a very brief answer. 0.87. What is the ratio of the Aid flow (current US$) in Cambodia in 1987 to that in 1991?
Offer a very short reply. 1.7. What is the ratio of the Aid flow (current US$) of Fiji in 1987 to that in 1991?
Provide a succinct answer. 1.44. What is the ratio of the Aid flow (current US$) of Nigeria in 1987 to that in 1991?
Ensure brevity in your answer.  1.5. What is the ratio of the Aid flow (current US$) in Suriname in 1987 to that in 1991?
Your answer should be compact. 0.39. What is the ratio of the Aid flow (current US$) of Cambodia in 1987 to that in 1992?
Ensure brevity in your answer.  0.09. What is the ratio of the Aid flow (current US$) in Fiji in 1987 to that in 1992?
Offer a very short reply. 0.76. What is the ratio of the Aid flow (current US$) in Nigeria in 1987 to that in 1992?
Ensure brevity in your answer.  0.58. What is the ratio of the Aid flow (current US$) in Suriname in 1987 to that in 1992?
Ensure brevity in your answer.  0.31. What is the ratio of the Aid flow (current US$) in Nigeria in 1988 to that in 1991?
Provide a short and direct response. 1.46. What is the ratio of the Aid flow (current US$) in Suriname in 1988 to that in 1991?
Offer a very short reply. 0.45. What is the ratio of the Aid flow (current US$) in Cambodia in 1988 to that in 1992?
Offer a terse response. 0.01. What is the ratio of the Aid flow (current US$) of Fiji in 1988 to that in 1992?
Provide a short and direct response. 0.71. What is the ratio of the Aid flow (current US$) in Nigeria in 1988 to that in 1992?
Keep it short and to the point. 0.57. What is the ratio of the Aid flow (current US$) in Suriname in 1988 to that in 1992?
Your answer should be very brief. 0.35. What is the ratio of the Aid flow (current US$) in Cambodia in 1991 to that in 1992?
Make the answer very short. 0.06. What is the ratio of the Aid flow (current US$) of Fiji in 1991 to that in 1992?
Provide a succinct answer. 0.53. What is the ratio of the Aid flow (current US$) in Nigeria in 1991 to that in 1992?
Provide a succinct answer. 0.39. What is the ratio of the Aid flow (current US$) of Suriname in 1991 to that in 1992?
Offer a terse response. 0.79. What is the difference between the highest and the second highest Aid flow (current US$) of Cambodia?
Your answer should be very brief. 2.37e+06. What is the difference between the highest and the second highest Aid flow (current US$) in Fiji?
Keep it short and to the point. 4.00e+04. What is the difference between the highest and the second highest Aid flow (current US$) of Nigeria?
Offer a very short reply. 1.90e+05. What is the difference between the highest and the second highest Aid flow (current US$) of Suriname?
Keep it short and to the point. 8.10e+05. What is the difference between the highest and the lowest Aid flow (current US$) in Cambodia?
Provide a succinct answer. 3.59e+06. What is the difference between the highest and the lowest Aid flow (current US$) in Fiji?
Keep it short and to the point. 1.40e+05. What is the difference between the highest and the lowest Aid flow (current US$) in Nigeria?
Provide a short and direct response. 4.40e+05. What is the difference between the highest and the lowest Aid flow (current US$) of Suriname?
Offer a very short reply. 3.33e+06. 